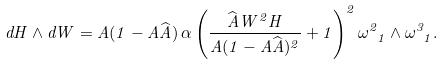Convert formula to latex. <formula><loc_0><loc_0><loc_500><loc_500>d H \wedge d W = A ( 1 - A \widehat { A } ) \, \alpha \left ( \frac { \widehat { A } W ^ { 2 } H } { A ( 1 - A \widehat { A } ) ^ { 2 } } + 1 \right ) ^ { 2 } \omega ^ { 2 } _ { \ 1 } \wedge \omega ^ { 3 } _ { \ 1 } .</formula> 